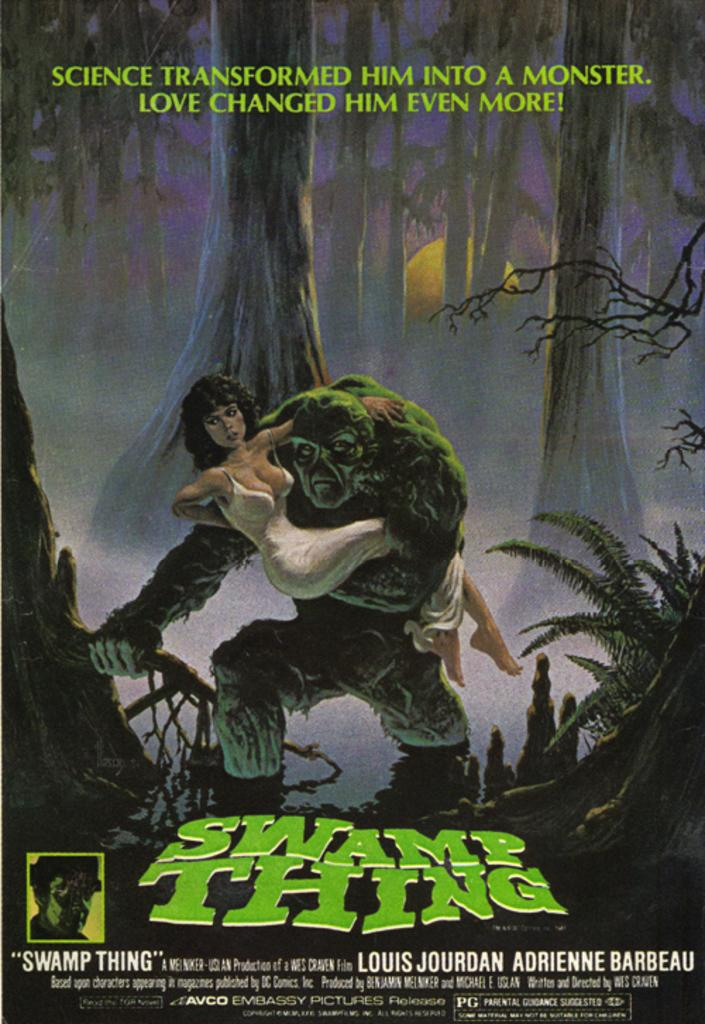<image>
Relay a brief, clear account of the picture shown. a poster with the title of swamp thing on it 